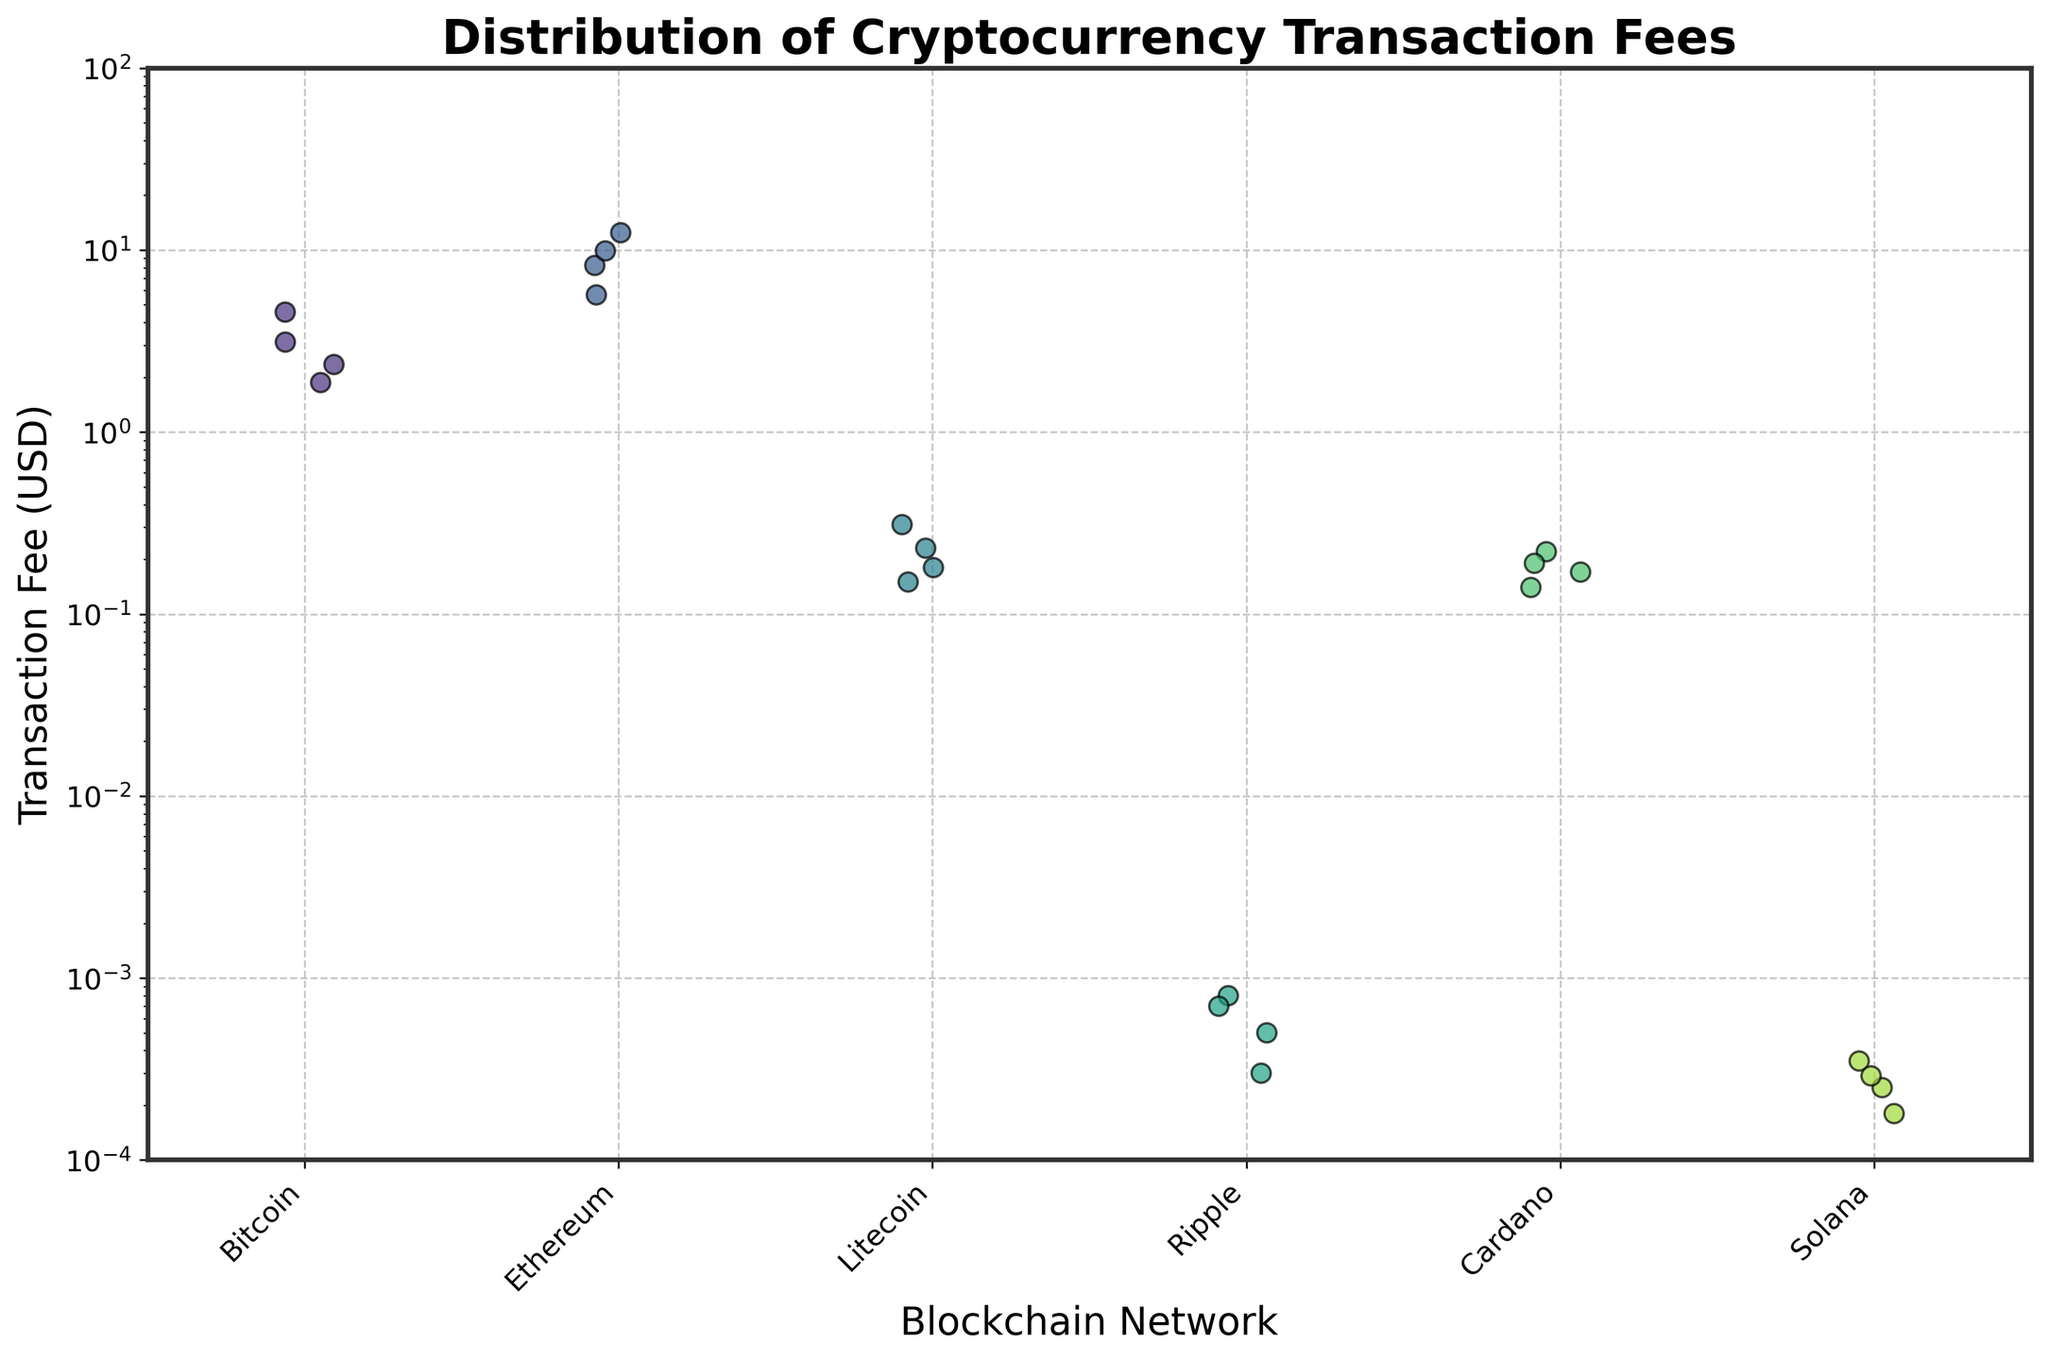Which network has the highest median transaction fee? To determine the highest median transaction fee, we observe the vertical spread of data points for each network and identify the median. Bitcoin and Ethereum have the widest spreads, indicating higher fees. Upon a closer look at individual data points, Ethereum's median fee is higher than Bitcoin.
Answer: Ethereum Which network has the lowest minimum transaction fee? To identify the network with the lowest minimum transaction fee, inspect the lowest data point for each network. Ripple and Solana have very low fees compared to the others. Among these, Ripple has lower values.
Answer: Ripple How does the distribution of transaction fees for Litecoin compare to Cardano? Compare the spread of data points for Litecoin and Cardano. Both networks have relatively low fees, but Litecoin’s fees range between 0.15-0.31 USD, while Cardano’s range between 0.14-0.22 USD. Litecoin's distribution shows a slightly higher spread.
Answer: Litecoin has a higher spread Is there any network where transaction fees remain under 1 USD for all data points? Look for networks where all data points are below 1 USD. Ripple and Solana have all their transaction fees well below 1 USD.
Answer: Yes, Ripple and Solana How does Bitcoin’s maximum transaction fee compare to Ethereum’s maximum transaction fee? To find the maximum fees for Bitcoin and Ethereum, identify the highest data points for each. Bitcoin's highest fee is 4.56 USD, while Ethereum's highest fee is 12.45 USD. Thus, Ethereum's maximum fee is higher.
Answer: Ethereum’s is higher Which network exhibits the most variability in transaction fees? Examine the spread of points for each network. A wide spread indicates high variability, whereas a narrow spread indicates low variability. Ethereum has the widest spread, indicating the most variability.
Answer: Ethereum What is the typical range of transaction fees for Solana? Observe the points for Solana and identify the range between the minimum and maximum values. Solana’s fees range from 0.00018 to 0.00035 USD.
Answer: 0.00018 to 0.00035 USD If you were to recommend a network based solely on low transaction fees, which would you choose? Look for the network with the lowest overall transaction fees. Ripple and Solana both have very low fees, but Ripple has the absolute lowest values consistently.
Answer: Ripple Are there any outliers visible in the transaction fees for Ethereum? To identify outliers, look for any points that are significantly distant from the rest of the distribution. Ethereum has several high fees, with one point notably higher at around 12.45 USD, indicating an outlier.
Answer: Yes, around 12.45 USD How does the overall fee structure of Bitcoin compare to that of Ethereum in terms of their respective plots? Compare the spread, median, and range of the Bitcoin and Ethereum plots. Bitcoin’s fees are generally lower and more clustered around the middle compared to Ethereum’s wider and higher spread.
Answer: Bitcoin’s overall fees are generally lower and more clustered 